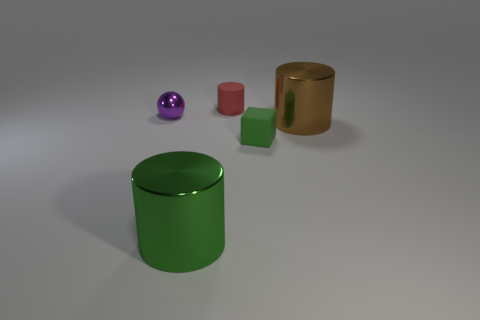Subtract 1 cylinders. How many cylinders are left? 2 Add 3 large blue spheres. How many objects exist? 8 Subtract all blocks. How many objects are left? 4 Subtract 0 yellow cylinders. How many objects are left? 5 Subtract all large things. Subtract all red rubber things. How many objects are left? 2 Add 3 green cubes. How many green cubes are left? 4 Add 2 big blue matte cubes. How many big blue matte cubes exist? 2 